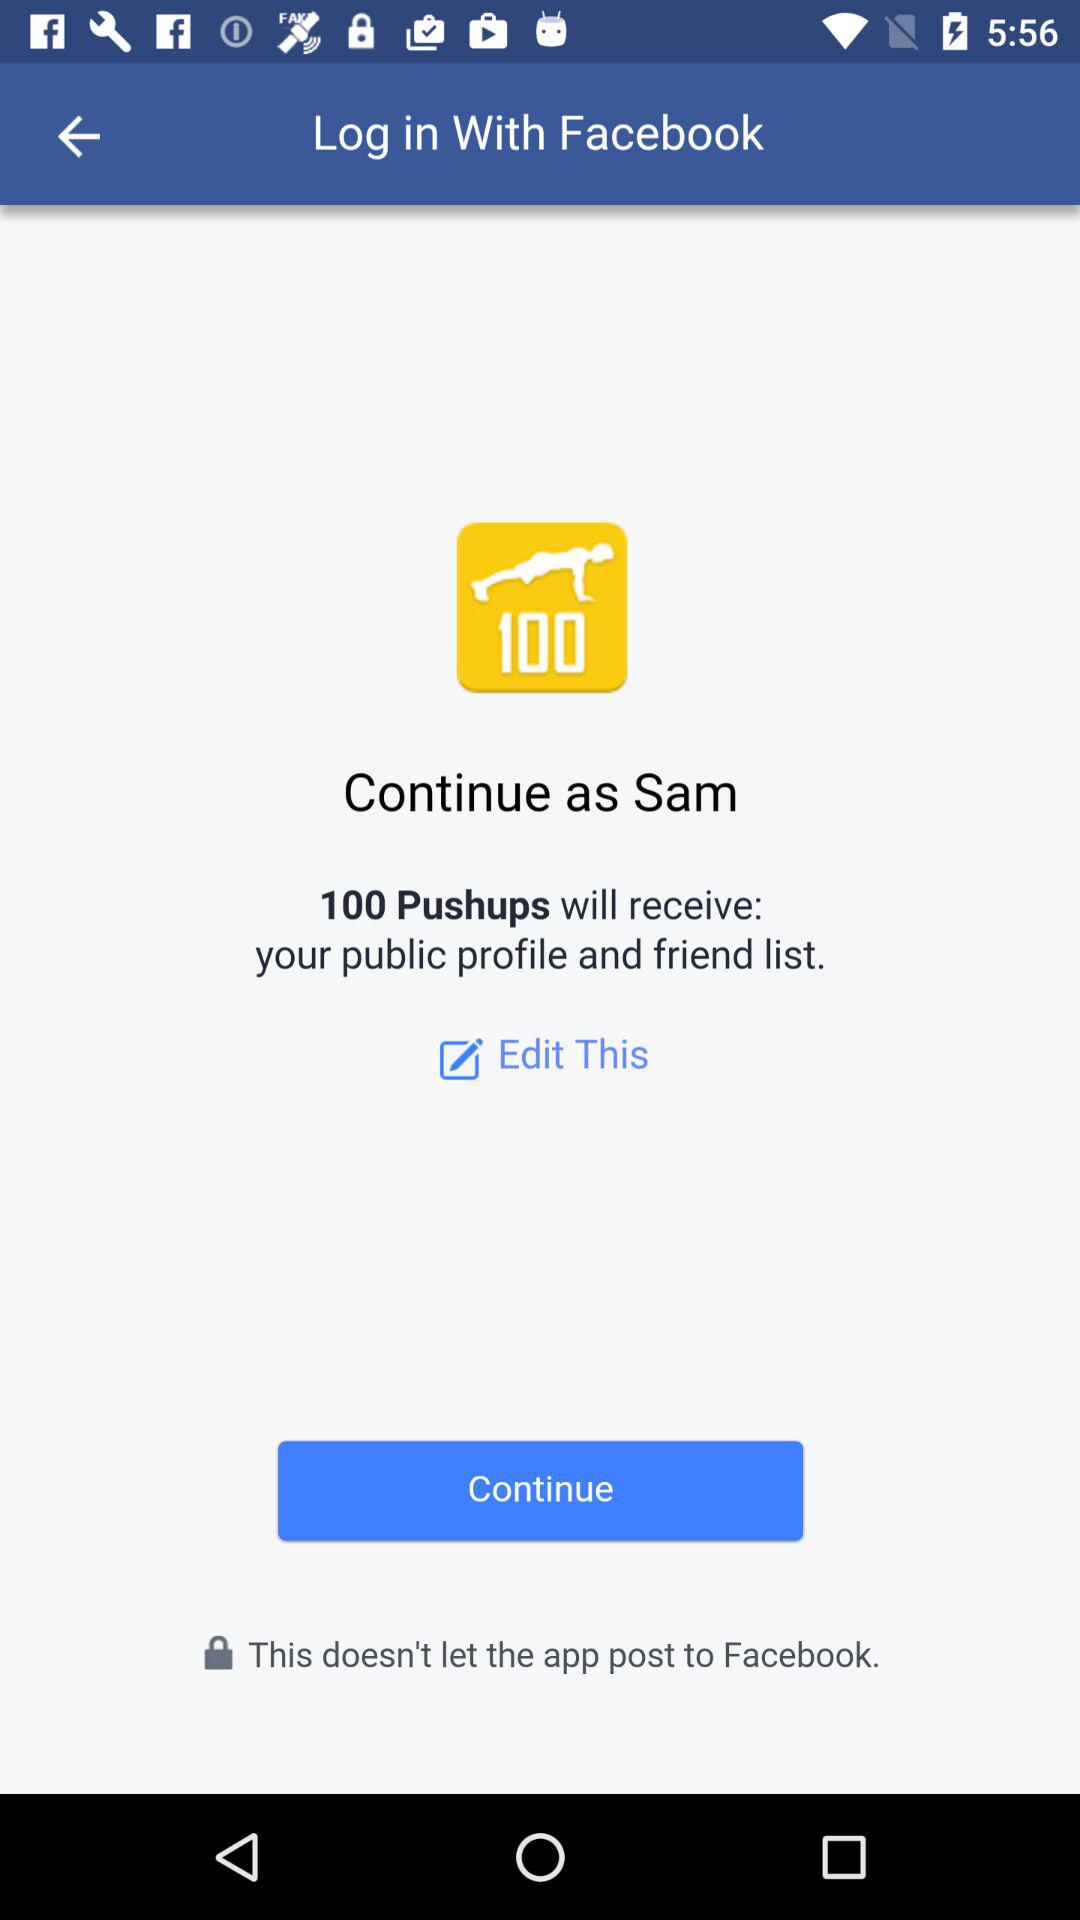What is the user's name? The user's name is Sam. 